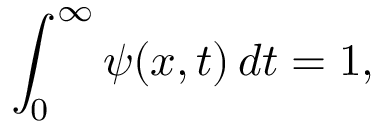Convert formula to latex. <formula><loc_0><loc_0><loc_500><loc_500>\int _ { 0 } ^ { \infty } \psi ( x , t ) \, d t = 1 ,</formula> 